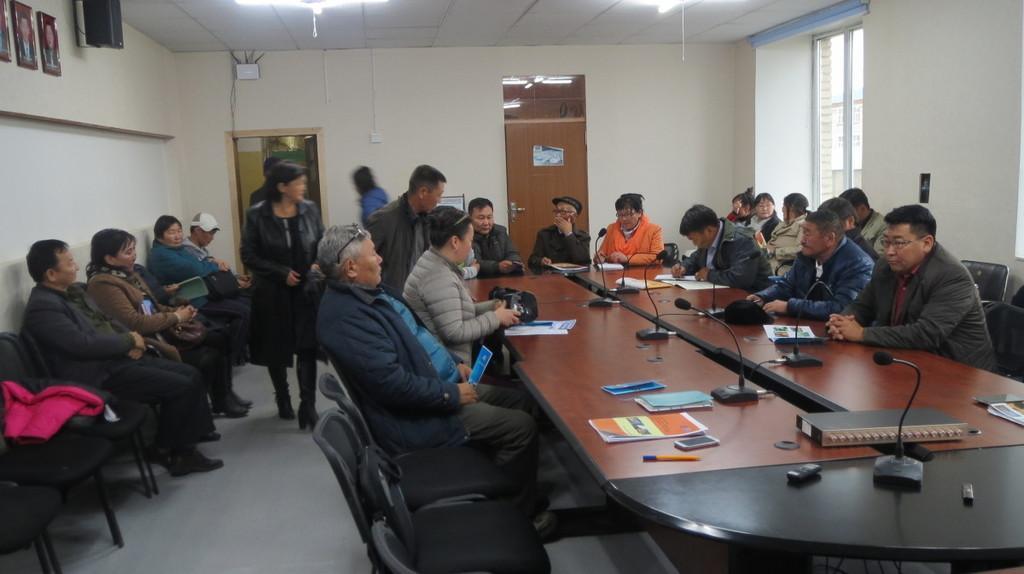In one or two sentences, can you explain what this image depicts? The image is inside the room. In the image there are group of people sitting on chair in front of a table, on table we can see a pen,book,mobile,microphone,paper. There are few people standing in the image on left side we can also see few people are sitting on chair on left side and there is also wall and photo frames attached to a wall, speakers. In background there is a door which is closed, on right side there is a window which is in white color. 